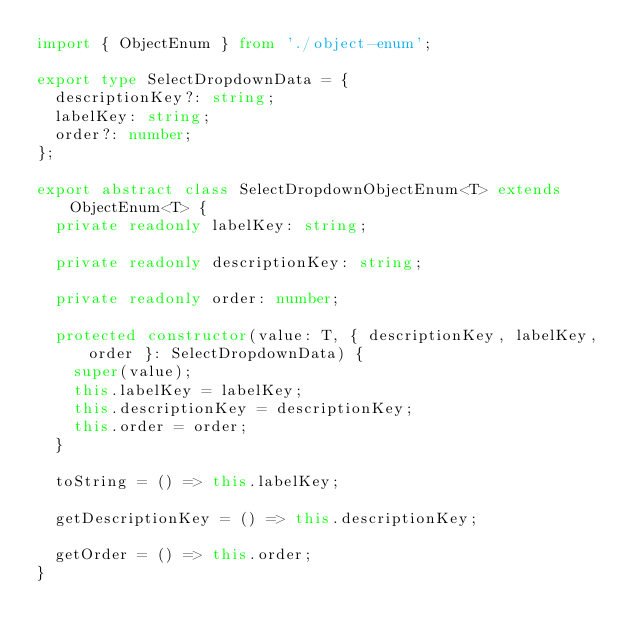Convert code to text. <code><loc_0><loc_0><loc_500><loc_500><_TypeScript_>import { ObjectEnum } from './object-enum';

export type SelectDropdownData = {
  descriptionKey?: string;
  labelKey: string;
  order?: number;
};

export abstract class SelectDropdownObjectEnum<T> extends ObjectEnum<T> {
  private readonly labelKey: string;

  private readonly descriptionKey: string;

  private readonly order: number;

  protected constructor(value: T, { descriptionKey, labelKey, order }: SelectDropdownData) {
    super(value);
    this.labelKey = labelKey;
    this.descriptionKey = descriptionKey;
    this.order = order;
  }

  toString = () => this.labelKey;

  getDescriptionKey = () => this.descriptionKey;

  getOrder = () => this.order;
}
</code> 